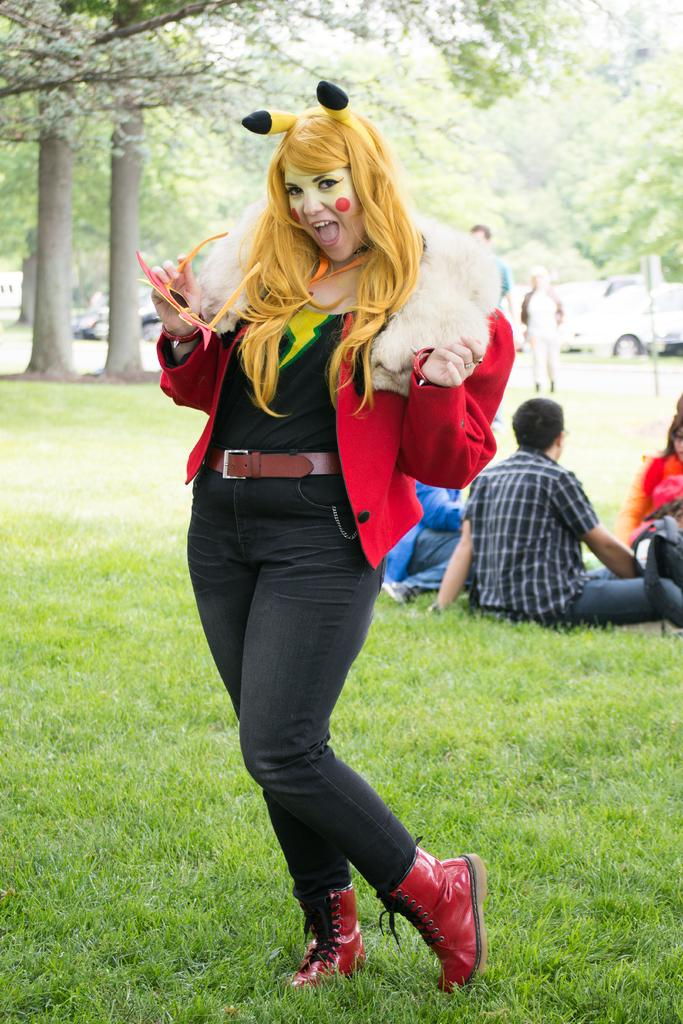What is the woman in the image doing? The woman is standing in the image and holding glasses. Can you describe the people behind the woman? There are people behind the woman, but their specific actions or appearances are not mentioned in the facts. What type of natural environment is visible in the image? Grass is visible in the image, and there are trees in the background. What else can be seen in the background of the image? Vehicles are present in the background of the image. What type of agreement is being discussed by the squirrel in the image? There is no squirrel present in the image, so no agreement can be discussed. 